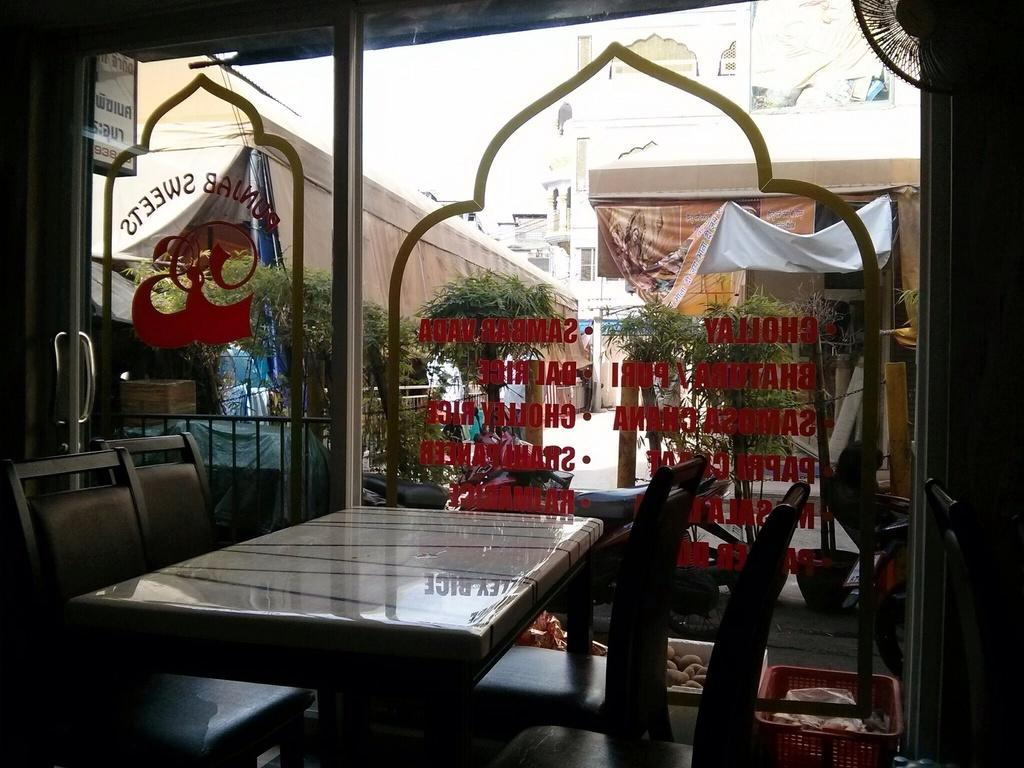What type of furniture is present in the image? There is a table and chairs in the image. What can be seen on the table? There are objects on the table. What other items are visible in the image? There are baskets in the image. What can be seen in the background of the image? There are buildings, house plants, tents, and additional objects in the background of the image. Can you tell me how many jellyfish are swimming in the background of the image? There are no jellyfish present in the image; the background features buildings, house plants, tents, and additional objects. 